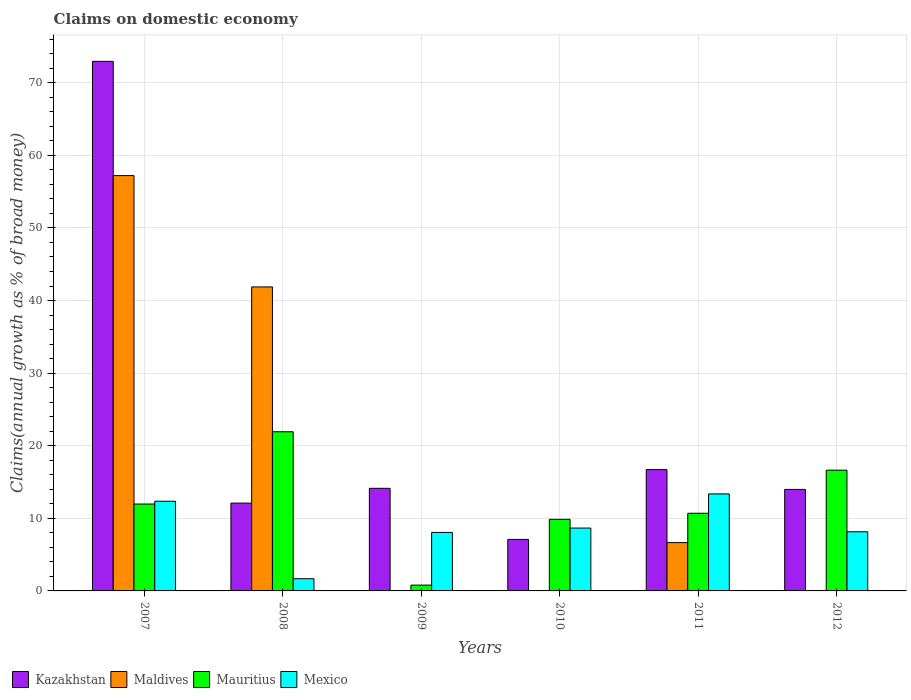Are the number of bars on each tick of the X-axis equal?
Keep it short and to the point. No. How many bars are there on the 3rd tick from the left?
Ensure brevity in your answer.  3. What is the label of the 6th group of bars from the left?
Give a very brief answer. 2012. What is the percentage of broad money claimed on domestic economy in Kazakhstan in 2010?
Your answer should be compact. 7.1. Across all years, what is the maximum percentage of broad money claimed on domestic economy in Mexico?
Make the answer very short. 13.36. Across all years, what is the minimum percentage of broad money claimed on domestic economy in Mauritius?
Provide a succinct answer. 0.8. In which year was the percentage of broad money claimed on domestic economy in Maldives maximum?
Provide a succinct answer. 2007. What is the total percentage of broad money claimed on domestic economy in Kazakhstan in the graph?
Make the answer very short. 136.96. What is the difference between the percentage of broad money claimed on domestic economy in Mexico in 2007 and that in 2009?
Offer a very short reply. 4.3. What is the difference between the percentage of broad money claimed on domestic economy in Maldives in 2009 and the percentage of broad money claimed on domestic economy in Kazakhstan in 2012?
Make the answer very short. -13.98. What is the average percentage of broad money claimed on domestic economy in Maldives per year?
Make the answer very short. 17.62. In the year 2011, what is the difference between the percentage of broad money claimed on domestic economy in Mexico and percentage of broad money claimed on domestic economy in Kazakhstan?
Provide a short and direct response. -3.35. In how many years, is the percentage of broad money claimed on domestic economy in Maldives greater than 34 %?
Offer a terse response. 2. What is the ratio of the percentage of broad money claimed on domestic economy in Mauritius in 2010 to that in 2011?
Your response must be concise. 0.92. Is the percentage of broad money claimed on domestic economy in Kazakhstan in 2008 less than that in 2010?
Make the answer very short. No. What is the difference between the highest and the second highest percentage of broad money claimed on domestic economy in Mexico?
Keep it short and to the point. 1.01. What is the difference between the highest and the lowest percentage of broad money claimed on domestic economy in Kazakhstan?
Provide a succinct answer. 65.85. Is it the case that in every year, the sum of the percentage of broad money claimed on domestic economy in Maldives and percentage of broad money claimed on domestic economy in Mauritius is greater than the percentage of broad money claimed on domestic economy in Mexico?
Offer a very short reply. No. How many bars are there?
Keep it short and to the point. 21. How many years are there in the graph?
Ensure brevity in your answer.  6. How are the legend labels stacked?
Ensure brevity in your answer.  Horizontal. What is the title of the graph?
Your answer should be compact. Claims on domestic economy. Does "Nicaragua" appear as one of the legend labels in the graph?
Give a very brief answer. No. What is the label or title of the X-axis?
Provide a succinct answer. Years. What is the label or title of the Y-axis?
Make the answer very short. Claims(annual growth as % of broad money). What is the Claims(annual growth as % of broad money) of Kazakhstan in 2007?
Provide a succinct answer. 72.94. What is the Claims(annual growth as % of broad money) in Maldives in 2007?
Give a very brief answer. 57.21. What is the Claims(annual growth as % of broad money) in Mauritius in 2007?
Keep it short and to the point. 11.97. What is the Claims(annual growth as % of broad money) of Mexico in 2007?
Provide a succinct answer. 12.35. What is the Claims(annual growth as % of broad money) in Kazakhstan in 2008?
Ensure brevity in your answer.  12.1. What is the Claims(annual growth as % of broad money) of Maldives in 2008?
Offer a terse response. 41.87. What is the Claims(annual growth as % of broad money) of Mauritius in 2008?
Make the answer very short. 21.92. What is the Claims(annual growth as % of broad money) of Mexico in 2008?
Make the answer very short. 1.68. What is the Claims(annual growth as % of broad money) of Kazakhstan in 2009?
Offer a terse response. 14.13. What is the Claims(annual growth as % of broad money) in Mauritius in 2009?
Your response must be concise. 0.8. What is the Claims(annual growth as % of broad money) in Mexico in 2009?
Your answer should be very brief. 8.06. What is the Claims(annual growth as % of broad money) in Kazakhstan in 2010?
Offer a terse response. 7.1. What is the Claims(annual growth as % of broad money) in Mauritius in 2010?
Offer a very short reply. 9.86. What is the Claims(annual growth as % of broad money) of Mexico in 2010?
Offer a very short reply. 8.66. What is the Claims(annual growth as % of broad money) of Kazakhstan in 2011?
Offer a terse response. 16.71. What is the Claims(annual growth as % of broad money) of Maldives in 2011?
Offer a terse response. 6.65. What is the Claims(annual growth as % of broad money) of Mauritius in 2011?
Keep it short and to the point. 10.7. What is the Claims(annual growth as % of broad money) in Mexico in 2011?
Provide a succinct answer. 13.36. What is the Claims(annual growth as % of broad money) of Kazakhstan in 2012?
Keep it short and to the point. 13.98. What is the Claims(annual growth as % of broad money) of Maldives in 2012?
Your answer should be compact. 0. What is the Claims(annual growth as % of broad money) of Mauritius in 2012?
Your response must be concise. 16.63. What is the Claims(annual growth as % of broad money) in Mexico in 2012?
Offer a very short reply. 8.14. Across all years, what is the maximum Claims(annual growth as % of broad money) of Kazakhstan?
Provide a short and direct response. 72.94. Across all years, what is the maximum Claims(annual growth as % of broad money) of Maldives?
Make the answer very short. 57.21. Across all years, what is the maximum Claims(annual growth as % of broad money) of Mauritius?
Provide a short and direct response. 21.92. Across all years, what is the maximum Claims(annual growth as % of broad money) in Mexico?
Offer a terse response. 13.36. Across all years, what is the minimum Claims(annual growth as % of broad money) in Kazakhstan?
Ensure brevity in your answer.  7.1. Across all years, what is the minimum Claims(annual growth as % of broad money) in Mauritius?
Your answer should be very brief. 0.8. Across all years, what is the minimum Claims(annual growth as % of broad money) in Mexico?
Provide a succinct answer. 1.68. What is the total Claims(annual growth as % of broad money) in Kazakhstan in the graph?
Offer a terse response. 136.96. What is the total Claims(annual growth as % of broad money) of Maldives in the graph?
Your response must be concise. 105.73. What is the total Claims(annual growth as % of broad money) in Mauritius in the graph?
Your answer should be very brief. 71.88. What is the total Claims(annual growth as % of broad money) in Mexico in the graph?
Keep it short and to the point. 52.26. What is the difference between the Claims(annual growth as % of broad money) of Kazakhstan in 2007 and that in 2008?
Your answer should be compact. 60.85. What is the difference between the Claims(annual growth as % of broad money) in Maldives in 2007 and that in 2008?
Give a very brief answer. 15.33. What is the difference between the Claims(annual growth as % of broad money) of Mauritius in 2007 and that in 2008?
Provide a succinct answer. -9.95. What is the difference between the Claims(annual growth as % of broad money) of Mexico in 2007 and that in 2008?
Offer a terse response. 10.67. What is the difference between the Claims(annual growth as % of broad money) of Kazakhstan in 2007 and that in 2009?
Make the answer very short. 58.81. What is the difference between the Claims(annual growth as % of broad money) of Mauritius in 2007 and that in 2009?
Offer a very short reply. 11.17. What is the difference between the Claims(annual growth as % of broad money) in Mexico in 2007 and that in 2009?
Offer a very short reply. 4.3. What is the difference between the Claims(annual growth as % of broad money) of Kazakhstan in 2007 and that in 2010?
Provide a short and direct response. 65.85. What is the difference between the Claims(annual growth as % of broad money) in Mauritius in 2007 and that in 2010?
Your answer should be compact. 2.11. What is the difference between the Claims(annual growth as % of broad money) in Mexico in 2007 and that in 2010?
Offer a terse response. 3.69. What is the difference between the Claims(annual growth as % of broad money) in Kazakhstan in 2007 and that in 2011?
Your answer should be very brief. 56.23. What is the difference between the Claims(annual growth as % of broad money) in Maldives in 2007 and that in 2011?
Keep it short and to the point. 50.55. What is the difference between the Claims(annual growth as % of broad money) of Mauritius in 2007 and that in 2011?
Your answer should be compact. 1.27. What is the difference between the Claims(annual growth as % of broad money) in Mexico in 2007 and that in 2011?
Keep it short and to the point. -1.01. What is the difference between the Claims(annual growth as % of broad money) in Kazakhstan in 2007 and that in 2012?
Give a very brief answer. 58.96. What is the difference between the Claims(annual growth as % of broad money) in Mauritius in 2007 and that in 2012?
Ensure brevity in your answer.  -4.66. What is the difference between the Claims(annual growth as % of broad money) of Mexico in 2007 and that in 2012?
Your response must be concise. 4.21. What is the difference between the Claims(annual growth as % of broad money) of Kazakhstan in 2008 and that in 2009?
Ensure brevity in your answer.  -2.04. What is the difference between the Claims(annual growth as % of broad money) of Mauritius in 2008 and that in 2009?
Your answer should be very brief. 21.12. What is the difference between the Claims(annual growth as % of broad money) in Mexico in 2008 and that in 2009?
Ensure brevity in your answer.  -6.38. What is the difference between the Claims(annual growth as % of broad money) in Kazakhstan in 2008 and that in 2010?
Your answer should be very brief. 5. What is the difference between the Claims(annual growth as % of broad money) of Mauritius in 2008 and that in 2010?
Your response must be concise. 12.06. What is the difference between the Claims(annual growth as % of broad money) of Mexico in 2008 and that in 2010?
Your response must be concise. -6.98. What is the difference between the Claims(annual growth as % of broad money) of Kazakhstan in 2008 and that in 2011?
Your answer should be very brief. -4.62. What is the difference between the Claims(annual growth as % of broad money) of Maldives in 2008 and that in 2011?
Make the answer very short. 35.22. What is the difference between the Claims(annual growth as % of broad money) in Mauritius in 2008 and that in 2011?
Offer a very short reply. 11.23. What is the difference between the Claims(annual growth as % of broad money) of Mexico in 2008 and that in 2011?
Your answer should be very brief. -11.68. What is the difference between the Claims(annual growth as % of broad money) of Kazakhstan in 2008 and that in 2012?
Your answer should be very brief. -1.89. What is the difference between the Claims(annual growth as % of broad money) of Mauritius in 2008 and that in 2012?
Give a very brief answer. 5.29. What is the difference between the Claims(annual growth as % of broad money) in Mexico in 2008 and that in 2012?
Provide a succinct answer. -6.46. What is the difference between the Claims(annual growth as % of broad money) in Kazakhstan in 2009 and that in 2010?
Offer a terse response. 7.04. What is the difference between the Claims(annual growth as % of broad money) of Mauritius in 2009 and that in 2010?
Make the answer very short. -9.06. What is the difference between the Claims(annual growth as % of broad money) in Mexico in 2009 and that in 2010?
Provide a short and direct response. -0.6. What is the difference between the Claims(annual growth as % of broad money) of Kazakhstan in 2009 and that in 2011?
Keep it short and to the point. -2.58. What is the difference between the Claims(annual growth as % of broad money) of Mauritius in 2009 and that in 2011?
Your response must be concise. -9.9. What is the difference between the Claims(annual growth as % of broad money) in Mexico in 2009 and that in 2011?
Provide a short and direct response. -5.3. What is the difference between the Claims(annual growth as % of broad money) of Kazakhstan in 2009 and that in 2012?
Your response must be concise. 0.15. What is the difference between the Claims(annual growth as % of broad money) in Mauritius in 2009 and that in 2012?
Provide a short and direct response. -15.83. What is the difference between the Claims(annual growth as % of broad money) of Mexico in 2009 and that in 2012?
Your answer should be compact. -0.09. What is the difference between the Claims(annual growth as % of broad money) of Kazakhstan in 2010 and that in 2011?
Your response must be concise. -9.62. What is the difference between the Claims(annual growth as % of broad money) in Mauritius in 2010 and that in 2011?
Ensure brevity in your answer.  -0.84. What is the difference between the Claims(annual growth as % of broad money) in Mexico in 2010 and that in 2011?
Your response must be concise. -4.7. What is the difference between the Claims(annual growth as % of broad money) in Kazakhstan in 2010 and that in 2012?
Your answer should be compact. -6.89. What is the difference between the Claims(annual growth as % of broad money) of Mauritius in 2010 and that in 2012?
Offer a terse response. -6.77. What is the difference between the Claims(annual growth as % of broad money) of Mexico in 2010 and that in 2012?
Provide a short and direct response. 0.52. What is the difference between the Claims(annual growth as % of broad money) of Kazakhstan in 2011 and that in 2012?
Give a very brief answer. 2.73. What is the difference between the Claims(annual growth as % of broad money) in Mauritius in 2011 and that in 2012?
Give a very brief answer. -5.93. What is the difference between the Claims(annual growth as % of broad money) in Mexico in 2011 and that in 2012?
Your answer should be very brief. 5.22. What is the difference between the Claims(annual growth as % of broad money) in Kazakhstan in 2007 and the Claims(annual growth as % of broad money) in Maldives in 2008?
Offer a very short reply. 31.07. What is the difference between the Claims(annual growth as % of broad money) of Kazakhstan in 2007 and the Claims(annual growth as % of broad money) of Mauritius in 2008?
Provide a short and direct response. 51.02. What is the difference between the Claims(annual growth as % of broad money) in Kazakhstan in 2007 and the Claims(annual growth as % of broad money) in Mexico in 2008?
Keep it short and to the point. 71.26. What is the difference between the Claims(annual growth as % of broad money) of Maldives in 2007 and the Claims(annual growth as % of broad money) of Mauritius in 2008?
Your response must be concise. 35.28. What is the difference between the Claims(annual growth as % of broad money) in Maldives in 2007 and the Claims(annual growth as % of broad money) in Mexico in 2008?
Keep it short and to the point. 55.53. What is the difference between the Claims(annual growth as % of broad money) of Mauritius in 2007 and the Claims(annual growth as % of broad money) of Mexico in 2008?
Make the answer very short. 10.29. What is the difference between the Claims(annual growth as % of broad money) of Kazakhstan in 2007 and the Claims(annual growth as % of broad money) of Mauritius in 2009?
Keep it short and to the point. 72.14. What is the difference between the Claims(annual growth as % of broad money) in Kazakhstan in 2007 and the Claims(annual growth as % of broad money) in Mexico in 2009?
Your response must be concise. 64.89. What is the difference between the Claims(annual growth as % of broad money) of Maldives in 2007 and the Claims(annual growth as % of broad money) of Mauritius in 2009?
Your response must be concise. 56.41. What is the difference between the Claims(annual growth as % of broad money) in Maldives in 2007 and the Claims(annual growth as % of broad money) in Mexico in 2009?
Provide a short and direct response. 49.15. What is the difference between the Claims(annual growth as % of broad money) of Mauritius in 2007 and the Claims(annual growth as % of broad money) of Mexico in 2009?
Your response must be concise. 3.91. What is the difference between the Claims(annual growth as % of broad money) in Kazakhstan in 2007 and the Claims(annual growth as % of broad money) in Mauritius in 2010?
Provide a succinct answer. 63.08. What is the difference between the Claims(annual growth as % of broad money) in Kazakhstan in 2007 and the Claims(annual growth as % of broad money) in Mexico in 2010?
Offer a very short reply. 64.28. What is the difference between the Claims(annual growth as % of broad money) of Maldives in 2007 and the Claims(annual growth as % of broad money) of Mauritius in 2010?
Give a very brief answer. 47.35. What is the difference between the Claims(annual growth as % of broad money) of Maldives in 2007 and the Claims(annual growth as % of broad money) of Mexico in 2010?
Provide a succinct answer. 48.55. What is the difference between the Claims(annual growth as % of broad money) in Mauritius in 2007 and the Claims(annual growth as % of broad money) in Mexico in 2010?
Ensure brevity in your answer.  3.31. What is the difference between the Claims(annual growth as % of broad money) of Kazakhstan in 2007 and the Claims(annual growth as % of broad money) of Maldives in 2011?
Make the answer very short. 66.29. What is the difference between the Claims(annual growth as % of broad money) of Kazakhstan in 2007 and the Claims(annual growth as % of broad money) of Mauritius in 2011?
Provide a short and direct response. 62.25. What is the difference between the Claims(annual growth as % of broad money) of Kazakhstan in 2007 and the Claims(annual growth as % of broad money) of Mexico in 2011?
Your answer should be very brief. 59.58. What is the difference between the Claims(annual growth as % of broad money) in Maldives in 2007 and the Claims(annual growth as % of broad money) in Mauritius in 2011?
Your response must be concise. 46.51. What is the difference between the Claims(annual growth as % of broad money) in Maldives in 2007 and the Claims(annual growth as % of broad money) in Mexico in 2011?
Ensure brevity in your answer.  43.84. What is the difference between the Claims(annual growth as % of broad money) in Mauritius in 2007 and the Claims(annual growth as % of broad money) in Mexico in 2011?
Your response must be concise. -1.39. What is the difference between the Claims(annual growth as % of broad money) in Kazakhstan in 2007 and the Claims(annual growth as % of broad money) in Mauritius in 2012?
Your response must be concise. 56.31. What is the difference between the Claims(annual growth as % of broad money) in Kazakhstan in 2007 and the Claims(annual growth as % of broad money) in Mexico in 2012?
Offer a terse response. 64.8. What is the difference between the Claims(annual growth as % of broad money) of Maldives in 2007 and the Claims(annual growth as % of broad money) of Mauritius in 2012?
Make the answer very short. 40.57. What is the difference between the Claims(annual growth as % of broad money) of Maldives in 2007 and the Claims(annual growth as % of broad money) of Mexico in 2012?
Provide a succinct answer. 49.06. What is the difference between the Claims(annual growth as % of broad money) in Mauritius in 2007 and the Claims(annual growth as % of broad money) in Mexico in 2012?
Your answer should be compact. 3.83. What is the difference between the Claims(annual growth as % of broad money) in Kazakhstan in 2008 and the Claims(annual growth as % of broad money) in Mauritius in 2009?
Provide a succinct answer. 11.3. What is the difference between the Claims(annual growth as % of broad money) in Kazakhstan in 2008 and the Claims(annual growth as % of broad money) in Mexico in 2009?
Keep it short and to the point. 4.04. What is the difference between the Claims(annual growth as % of broad money) of Maldives in 2008 and the Claims(annual growth as % of broad money) of Mauritius in 2009?
Your response must be concise. 41.08. What is the difference between the Claims(annual growth as % of broad money) in Maldives in 2008 and the Claims(annual growth as % of broad money) in Mexico in 2009?
Make the answer very short. 33.82. What is the difference between the Claims(annual growth as % of broad money) in Mauritius in 2008 and the Claims(annual growth as % of broad money) in Mexico in 2009?
Your answer should be compact. 13.87. What is the difference between the Claims(annual growth as % of broad money) in Kazakhstan in 2008 and the Claims(annual growth as % of broad money) in Mauritius in 2010?
Offer a very short reply. 2.24. What is the difference between the Claims(annual growth as % of broad money) in Kazakhstan in 2008 and the Claims(annual growth as % of broad money) in Mexico in 2010?
Give a very brief answer. 3.44. What is the difference between the Claims(annual growth as % of broad money) of Maldives in 2008 and the Claims(annual growth as % of broad money) of Mauritius in 2010?
Offer a very short reply. 32.01. What is the difference between the Claims(annual growth as % of broad money) in Maldives in 2008 and the Claims(annual growth as % of broad money) in Mexico in 2010?
Keep it short and to the point. 33.21. What is the difference between the Claims(annual growth as % of broad money) of Mauritius in 2008 and the Claims(annual growth as % of broad money) of Mexico in 2010?
Give a very brief answer. 13.26. What is the difference between the Claims(annual growth as % of broad money) of Kazakhstan in 2008 and the Claims(annual growth as % of broad money) of Maldives in 2011?
Ensure brevity in your answer.  5.44. What is the difference between the Claims(annual growth as % of broad money) of Kazakhstan in 2008 and the Claims(annual growth as % of broad money) of Mauritius in 2011?
Provide a short and direct response. 1.4. What is the difference between the Claims(annual growth as % of broad money) in Kazakhstan in 2008 and the Claims(annual growth as % of broad money) in Mexico in 2011?
Give a very brief answer. -1.27. What is the difference between the Claims(annual growth as % of broad money) in Maldives in 2008 and the Claims(annual growth as % of broad money) in Mauritius in 2011?
Give a very brief answer. 31.18. What is the difference between the Claims(annual growth as % of broad money) in Maldives in 2008 and the Claims(annual growth as % of broad money) in Mexico in 2011?
Your response must be concise. 28.51. What is the difference between the Claims(annual growth as % of broad money) of Mauritius in 2008 and the Claims(annual growth as % of broad money) of Mexico in 2011?
Offer a very short reply. 8.56. What is the difference between the Claims(annual growth as % of broad money) in Kazakhstan in 2008 and the Claims(annual growth as % of broad money) in Mauritius in 2012?
Your response must be concise. -4.54. What is the difference between the Claims(annual growth as % of broad money) in Kazakhstan in 2008 and the Claims(annual growth as % of broad money) in Mexico in 2012?
Your answer should be very brief. 3.95. What is the difference between the Claims(annual growth as % of broad money) in Maldives in 2008 and the Claims(annual growth as % of broad money) in Mauritius in 2012?
Give a very brief answer. 25.24. What is the difference between the Claims(annual growth as % of broad money) in Maldives in 2008 and the Claims(annual growth as % of broad money) in Mexico in 2012?
Ensure brevity in your answer.  33.73. What is the difference between the Claims(annual growth as % of broad money) of Mauritius in 2008 and the Claims(annual growth as % of broad money) of Mexico in 2012?
Provide a short and direct response. 13.78. What is the difference between the Claims(annual growth as % of broad money) of Kazakhstan in 2009 and the Claims(annual growth as % of broad money) of Mauritius in 2010?
Keep it short and to the point. 4.27. What is the difference between the Claims(annual growth as % of broad money) in Kazakhstan in 2009 and the Claims(annual growth as % of broad money) in Mexico in 2010?
Offer a terse response. 5.47. What is the difference between the Claims(annual growth as % of broad money) in Mauritius in 2009 and the Claims(annual growth as % of broad money) in Mexico in 2010?
Your answer should be very brief. -7.86. What is the difference between the Claims(annual growth as % of broad money) of Kazakhstan in 2009 and the Claims(annual growth as % of broad money) of Maldives in 2011?
Give a very brief answer. 7.48. What is the difference between the Claims(annual growth as % of broad money) in Kazakhstan in 2009 and the Claims(annual growth as % of broad money) in Mauritius in 2011?
Your response must be concise. 3.44. What is the difference between the Claims(annual growth as % of broad money) of Kazakhstan in 2009 and the Claims(annual growth as % of broad money) of Mexico in 2011?
Keep it short and to the point. 0.77. What is the difference between the Claims(annual growth as % of broad money) in Mauritius in 2009 and the Claims(annual growth as % of broad money) in Mexico in 2011?
Provide a succinct answer. -12.56. What is the difference between the Claims(annual growth as % of broad money) of Kazakhstan in 2009 and the Claims(annual growth as % of broad money) of Mauritius in 2012?
Provide a short and direct response. -2.5. What is the difference between the Claims(annual growth as % of broad money) of Kazakhstan in 2009 and the Claims(annual growth as % of broad money) of Mexico in 2012?
Make the answer very short. 5.99. What is the difference between the Claims(annual growth as % of broad money) of Mauritius in 2009 and the Claims(annual growth as % of broad money) of Mexico in 2012?
Make the answer very short. -7.35. What is the difference between the Claims(annual growth as % of broad money) of Kazakhstan in 2010 and the Claims(annual growth as % of broad money) of Maldives in 2011?
Offer a very short reply. 0.44. What is the difference between the Claims(annual growth as % of broad money) in Kazakhstan in 2010 and the Claims(annual growth as % of broad money) in Mauritius in 2011?
Your answer should be very brief. -3.6. What is the difference between the Claims(annual growth as % of broad money) in Kazakhstan in 2010 and the Claims(annual growth as % of broad money) in Mexico in 2011?
Offer a very short reply. -6.26. What is the difference between the Claims(annual growth as % of broad money) of Mauritius in 2010 and the Claims(annual growth as % of broad money) of Mexico in 2011?
Your answer should be compact. -3.5. What is the difference between the Claims(annual growth as % of broad money) in Kazakhstan in 2010 and the Claims(annual growth as % of broad money) in Mauritius in 2012?
Make the answer very short. -9.54. What is the difference between the Claims(annual growth as % of broad money) of Kazakhstan in 2010 and the Claims(annual growth as % of broad money) of Mexico in 2012?
Make the answer very short. -1.05. What is the difference between the Claims(annual growth as % of broad money) of Mauritius in 2010 and the Claims(annual growth as % of broad money) of Mexico in 2012?
Your response must be concise. 1.72. What is the difference between the Claims(annual growth as % of broad money) in Kazakhstan in 2011 and the Claims(annual growth as % of broad money) in Mauritius in 2012?
Your response must be concise. 0.08. What is the difference between the Claims(annual growth as % of broad money) in Kazakhstan in 2011 and the Claims(annual growth as % of broad money) in Mexico in 2012?
Your answer should be compact. 8.57. What is the difference between the Claims(annual growth as % of broad money) of Maldives in 2011 and the Claims(annual growth as % of broad money) of Mauritius in 2012?
Keep it short and to the point. -9.98. What is the difference between the Claims(annual growth as % of broad money) of Maldives in 2011 and the Claims(annual growth as % of broad money) of Mexico in 2012?
Make the answer very short. -1.49. What is the difference between the Claims(annual growth as % of broad money) of Mauritius in 2011 and the Claims(annual growth as % of broad money) of Mexico in 2012?
Provide a succinct answer. 2.55. What is the average Claims(annual growth as % of broad money) of Kazakhstan per year?
Offer a very short reply. 22.83. What is the average Claims(annual growth as % of broad money) in Maldives per year?
Provide a succinct answer. 17.62. What is the average Claims(annual growth as % of broad money) of Mauritius per year?
Offer a terse response. 11.98. What is the average Claims(annual growth as % of broad money) in Mexico per year?
Provide a short and direct response. 8.71. In the year 2007, what is the difference between the Claims(annual growth as % of broad money) of Kazakhstan and Claims(annual growth as % of broad money) of Maldives?
Give a very brief answer. 15.74. In the year 2007, what is the difference between the Claims(annual growth as % of broad money) in Kazakhstan and Claims(annual growth as % of broad money) in Mauritius?
Make the answer very short. 60.97. In the year 2007, what is the difference between the Claims(annual growth as % of broad money) of Kazakhstan and Claims(annual growth as % of broad money) of Mexico?
Offer a very short reply. 60.59. In the year 2007, what is the difference between the Claims(annual growth as % of broad money) of Maldives and Claims(annual growth as % of broad money) of Mauritius?
Offer a very short reply. 45.24. In the year 2007, what is the difference between the Claims(annual growth as % of broad money) of Maldives and Claims(annual growth as % of broad money) of Mexico?
Offer a very short reply. 44.85. In the year 2007, what is the difference between the Claims(annual growth as % of broad money) of Mauritius and Claims(annual growth as % of broad money) of Mexico?
Offer a terse response. -0.38. In the year 2008, what is the difference between the Claims(annual growth as % of broad money) of Kazakhstan and Claims(annual growth as % of broad money) of Maldives?
Provide a succinct answer. -29.78. In the year 2008, what is the difference between the Claims(annual growth as % of broad money) in Kazakhstan and Claims(annual growth as % of broad money) in Mauritius?
Make the answer very short. -9.83. In the year 2008, what is the difference between the Claims(annual growth as % of broad money) in Kazakhstan and Claims(annual growth as % of broad money) in Mexico?
Provide a short and direct response. 10.41. In the year 2008, what is the difference between the Claims(annual growth as % of broad money) of Maldives and Claims(annual growth as % of broad money) of Mauritius?
Offer a very short reply. 19.95. In the year 2008, what is the difference between the Claims(annual growth as % of broad money) in Maldives and Claims(annual growth as % of broad money) in Mexico?
Provide a succinct answer. 40.19. In the year 2008, what is the difference between the Claims(annual growth as % of broad money) of Mauritius and Claims(annual growth as % of broad money) of Mexico?
Keep it short and to the point. 20.24. In the year 2009, what is the difference between the Claims(annual growth as % of broad money) of Kazakhstan and Claims(annual growth as % of broad money) of Mauritius?
Ensure brevity in your answer.  13.33. In the year 2009, what is the difference between the Claims(annual growth as % of broad money) in Kazakhstan and Claims(annual growth as % of broad money) in Mexico?
Give a very brief answer. 6.08. In the year 2009, what is the difference between the Claims(annual growth as % of broad money) of Mauritius and Claims(annual growth as % of broad money) of Mexico?
Your response must be concise. -7.26. In the year 2010, what is the difference between the Claims(annual growth as % of broad money) of Kazakhstan and Claims(annual growth as % of broad money) of Mauritius?
Your response must be concise. -2.76. In the year 2010, what is the difference between the Claims(annual growth as % of broad money) of Kazakhstan and Claims(annual growth as % of broad money) of Mexico?
Keep it short and to the point. -1.56. In the year 2010, what is the difference between the Claims(annual growth as % of broad money) of Mauritius and Claims(annual growth as % of broad money) of Mexico?
Your answer should be compact. 1.2. In the year 2011, what is the difference between the Claims(annual growth as % of broad money) in Kazakhstan and Claims(annual growth as % of broad money) in Maldives?
Make the answer very short. 10.06. In the year 2011, what is the difference between the Claims(annual growth as % of broad money) of Kazakhstan and Claims(annual growth as % of broad money) of Mauritius?
Keep it short and to the point. 6.02. In the year 2011, what is the difference between the Claims(annual growth as % of broad money) in Kazakhstan and Claims(annual growth as % of broad money) in Mexico?
Keep it short and to the point. 3.35. In the year 2011, what is the difference between the Claims(annual growth as % of broad money) in Maldives and Claims(annual growth as % of broad money) in Mauritius?
Give a very brief answer. -4.04. In the year 2011, what is the difference between the Claims(annual growth as % of broad money) of Maldives and Claims(annual growth as % of broad money) of Mexico?
Your response must be concise. -6.71. In the year 2011, what is the difference between the Claims(annual growth as % of broad money) of Mauritius and Claims(annual growth as % of broad money) of Mexico?
Your response must be concise. -2.66. In the year 2012, what is the difference between the Claims(annual growth as % of broad money) in Kazakhstan and Claims(annual growth as % of broad money) in Mauritius?
Ensure brevity in your answer.  -2.65. In the year 2012, what is the difference between the Claims(annual growth as % of broad money) of Kazakhstan and Claims(annual growth as % of broad money) of Mexico?
Keep it short and to the point. 5.84. In the year 2012, what is the difference between the Claims(annual growth as % of broad money) of Mauritius and Claims(annual growth as % of broad money) of Mexico?
Offer a very short reply. 8.49. What is the ratio of the Claims(annual growth as % of broad money) in Kazakhstan in 2007 to that in 2008?
Offer a terse response. 6.03. What is the ratio of the Claims(annual growth as % of broad money) in Maldives in 2007 to that in 2008?
Your response must be concise. 1.37. What is the ratio of the Claims(annual growth as % of broad money) in Mauritius in 2007 to that in 2008?
Provide a succinct answer. 0.55. What is the ratio of the Claims(annual growth as % of broad money) of Mexico in 2007 to that in 2008?
Ensure brevity in your answer.  7.35. What is the ratio of the Claims(annual growth as % of broad money) in Kazakhstan in 2007 to that in 2009?
Your response must be concise. 5.16. What is the ratio of the Claims(annual growth as % of broad money) of Mauritius in 2007 to that in 2009?
Offer a terse response. 14.99. What is the ratio of the Claims(annual growth as % of broad money) of Mexico in 2007 to that in 2009?
Provide a short and direct response. 1.53. What is the ratio of the Claims(annual growth as % of broad money) in Kazakhstan in 2007 to that in 2010?
Offer a very short reply. 10.28. What is the ratio of the Claims(annual growth as % of broad money) of Mauritius in 2007 to that in 2010?
Keep it short and to the point. 1.21. What is the ratio of the Claims(annual growth as % of broad money) of Mexico in 2007 to that in 2010?
Provide a succinct answer. 1.43. What is the ratio of the Claims(annual growth as % of broad money) of Kazakhstan in 2007 to that in 2011?
Your answer should be very brief. 4.36. What is the ratio of the Claims(annual growth as % of broad money) in Maldives in 2007 to that in 2011?
Your response must be concise. 8.6. What is the ratio of the Claims(annual growth as % of broad money) in Mauritius in 2007 to that in 2011?
Your answer should be compact. 1.12. What is the ratio of the Claims(annual growth as % of broad money) in Mexico in 2007 to that in 2011?
Offer a terse response. 0.92. What is the ratio of the Claims(annual growth as % of broad money) in Kazakhstan in 2007 to that in 2012?
Your response must be concise. 5.22. What is the ratio of the Claims(annual growth as % of broad money) in Mauritius in 2007 to that in 2012?
Provide a short and direct response. 0.72. What is the ratio of the Claims(annual growth as % of broad money) in Mexico in 2007 to that in 2012?
Offer a very short reply. 1.52. What is the ratio of the Claims(annual growth as % of broad money) of Kazakhstan in 2008 to that in 2009?
Make the answer very short. 0.86. What is the ratio of the Claims(annual growth as % of broad money) in Mauritius in 2008 to that in 2009?
Your answer should be compact. 27.45. What is the ratio of the Claims(annual growth as % of broad money) in Mexico in 2008 to that in 2009?
Your response must be concise. 0.21. What is the ratio of the Claims(annual growth as % of broad money) of Kazakhstan in 2008 to that in 2010?
Your answer should be very brief. 1.7. What is the ratio of the Claims(annual growth as % of broad money) of Mauritius in 2008 to that in 2010?
Ensure brevity in your answer.  2.22. What is the ratio of the Claims(annual growth as % of broad money) of Mexico in 2008 to that in 2010?
Your answer should be compact. 0.19. What is the ratio of the Claims(annual growth as % of broad money) in Kazakhstan in 2008 to that in 2011?
Provide a succinct answer. 0.72. What is the ratio of the Claims(annual growth as % of broad money) of Maldives in 2008 to that in 2011?
Keep it short and to the point. 6.29. What is the ratio of the Claims(annual growth as % of broad money) in Mauritius in 2008 to that in 2011?
Your response must be concise. 2.05. What is the ratio of the Claims(annual growth as % of broad money) in Mexico in 2008 to that in 2011?
Provide a succinct answer. 0.13. What is the ratio of the Claims(annual growth as % of broad money) of Kazakhstan in 2008 to that in 2012?
Offer a terse response. 0.87. What is the ratio of the Claims(annual growth as % of broad money) of Mauritius in 2008 to that in 2012?
Your answer should be compact. 1.32. What is the ratio of the Claims(annual growth as % of broad money) of Mexico in 2008 to that in 2012?
Your response must be concise. 0.21. What is the ratio of the Claims(annual growth as % of broad money) in Kazakhstan in 2009 to that in 2010?
Offer a very short reply. 1.99. What is the ratio of the Claims(annual growth as % of broad money) of Mauritius in 2009 to that in 2010?
Your response must be concise. 0.08. What is the ratio of the Claims(annual growth as % of broad money) of Mexico in 2009 to that in 2010?
Give a very brief answer. 0.93. What is the ratio of the Claims(annual growth as % of broad money) of Kazakhstan in 2009 to that in 2011?
Offer a terse response. 0.85. What is the ratio of the Claims(annual growth as % of broad money) in Mauritius in 2009 to that in 2011?
Your answer should be compact. 0.07. What is the ratio of the Claims(annual growth as % of broad money) in Mexico in 2009 to that in 2011?
Your answer should be very brief. 0.6. What is the ratio of the Claims(annual growth as % of broad money) in Kazakhstan in 2009 to that in 2012?
Offer a terse response. 1.01. What is the ratio of the Claims(annual growth as % of broad money) of Mauritius in 2009 to that in 2012?
Provide a succinct answer. 0.05. What is the ratio of the Claims(annual growth as % of broad money) of Mexico in 2009 to that in 2012?
Ensure brevity in your answer.  0.99. What is the ratio of the Claims(annual growth as % of broad money) in Kazakhstan in 2010 to that in 2011?
Make the answer very short. 0.42. What is the ratio of the Claims(annual growth as % of broad money) in Mauritius in 2010 to that in 2011?
Offer a very short reply. 0.92. What is the ratio of the Claims(annual growth as % of broad money) in Mexico in 2010 to that in 2011?
Your answer should be compact. 0.65. What is the ratio of the Claims(annual growth as % of broad money) in Kazakhstan in 2010 to that in 2012?
Provide a short and direct response. 0.51. What is the ratio of the Claims(annual growth as % of broad money) of Mauritius in 2010 to that in 2012?
Keep it short and to the point. 0.59. What is the ratio of the Claims(annual growth as % of broad money) in Mexico in 2010 to that in 2012?
Give a very brief answer. 1.06. What is the ratio of the Claims(annual growth as % of broad money) of Kazakhstan in 2011 to that in 2012?
Your answer should be compact. 1.2. What is the ratio of the Claims(annual growth as % of broad money) of Mauritius in 2011 to that in 2012?
Provide a short and direct response. 0.64. What is the ratio of the Claims(annual growth as % of broad money) of Mexico in 2011 to that in 2012?
Offer a very short reply. 1.64. What is the difference between the highest and the second highest Claims(annual growth as % of broad money) of Kazakhstan?
Provide a succinct answer. 56.23. What is the difference between the highest and the second highest Claims(annual growth as % of broad money) in Maldives?
Make the answer very short. 15.33. What is the difference between the highest and the second highest Claims(annual growth as % of broad money) of Mauritius?
Provide a succinct answer. 5.29. What is the difference between the highest and the second highest Claims(annual growth as % of broad money) in Mexico?
Your answer should be compact. 1.01. What is the difference between the highest and the lowest Claims(annual growth as % of broad money) in Kazakhstan?
Keep it short and to the point. 65.85. What is the difference between the highest and the lowest Claims(annual growth as % of broad money) in Maldives?
Ensure brevity in your answer.  57.21. What is the difference between the highest and the lowest Claims(annual growth as % of broad money) in Mauritius?
Your response must be concise. 21.12. What is the difference between the highest and the lowest Claims(annual growth as % of broad money) in Mexico?
Offer a very short reply. 11.68. 